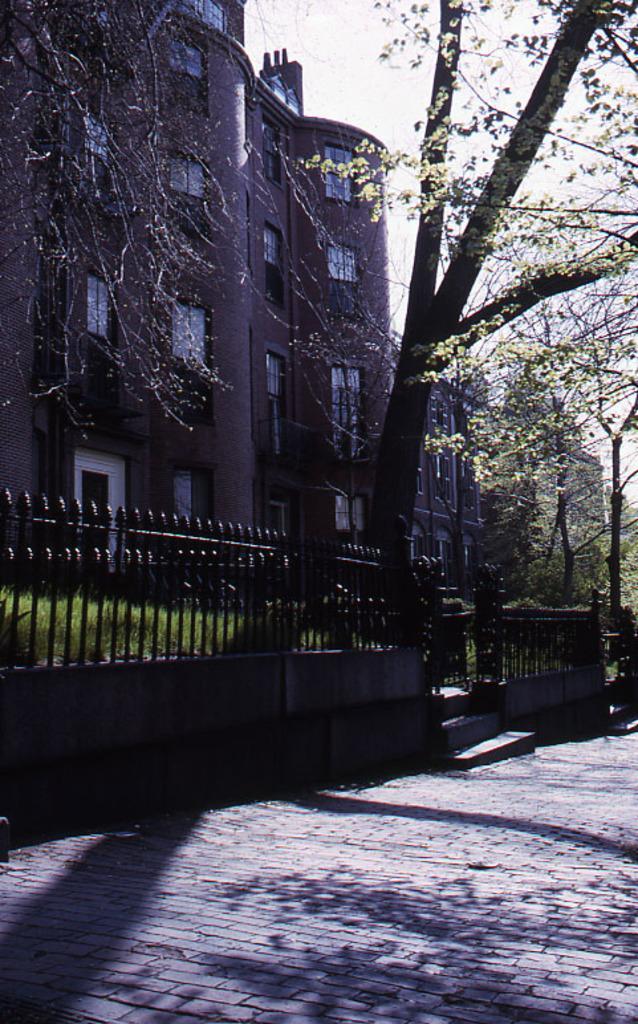Describe this image in one or two sentences. In this image I can see the road. To the side of the road I can see the railing, grass and many trees. In the background I can see the building with windows and the sky. 